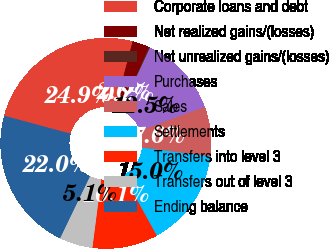Convert chart. <chart><loc_0><loc_0><loc_500><loc_500><pie_chart><fcel>Corporate loans and debt<fcel>Net realized gains/(losses)<fcel>Net unrealized gains/(losses)<fcel>Purchases<fcel>Sales<fcel>Settlements<fcel>Transfers into level 3<fcel>Transfers out of level 3<fcel>Ending balance<nl><fcel>24.89%<fcel>2.63%<fcel>0.16%<fcel>12.53%<fcel>7.58%<fcel>15.0%<fcel>10.05%<fcel>5.11%<fcel>22.04%<nl></chart> 